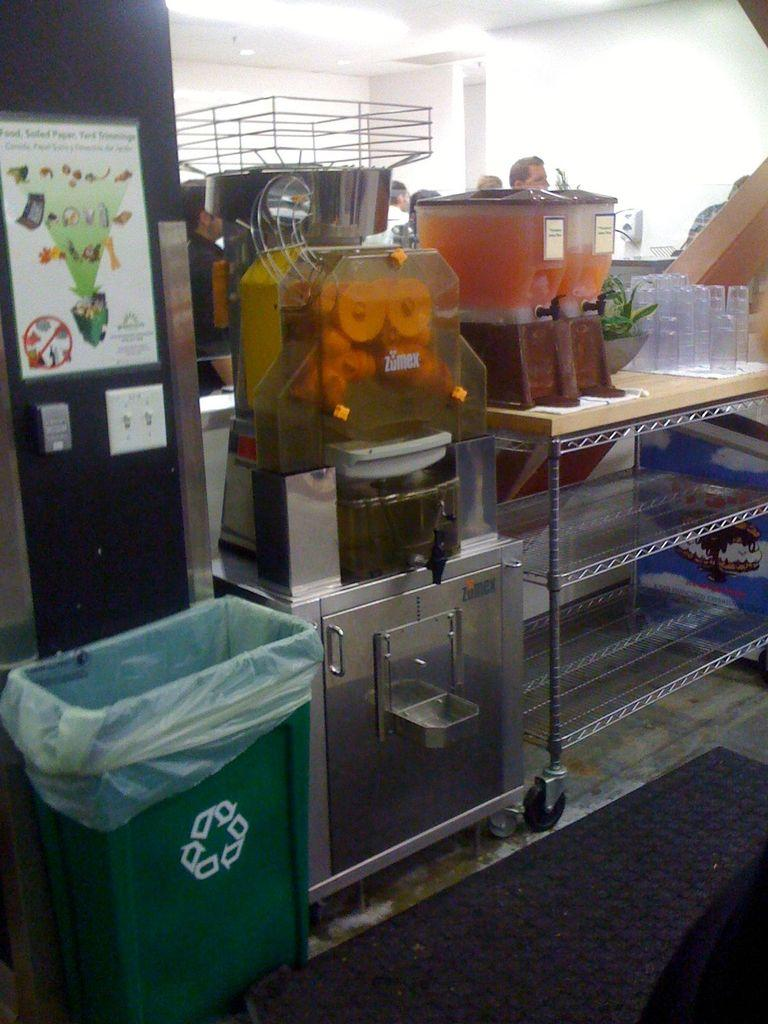What can be seen in the background of the image? There is a wall and people in the background of the image. What is located on the table in the image? There is a table in the image with glasses, juice containers, and a machine on it. What is present on the wall in the image? There is a poster on a wall in the image. What type of container is visible in the image? There are juice containers on the table in the image. What can be used for disposing of waste in the image? There is a trash can in the image. What type of surface is visible in the image? There is a floor visible in the image. Where are the toys located in the image? There are no toys present in the image. What type of sheet is covering the table in the image? There is no sheet present in the image; the table has glasses, juice containers, and a machine on it. 